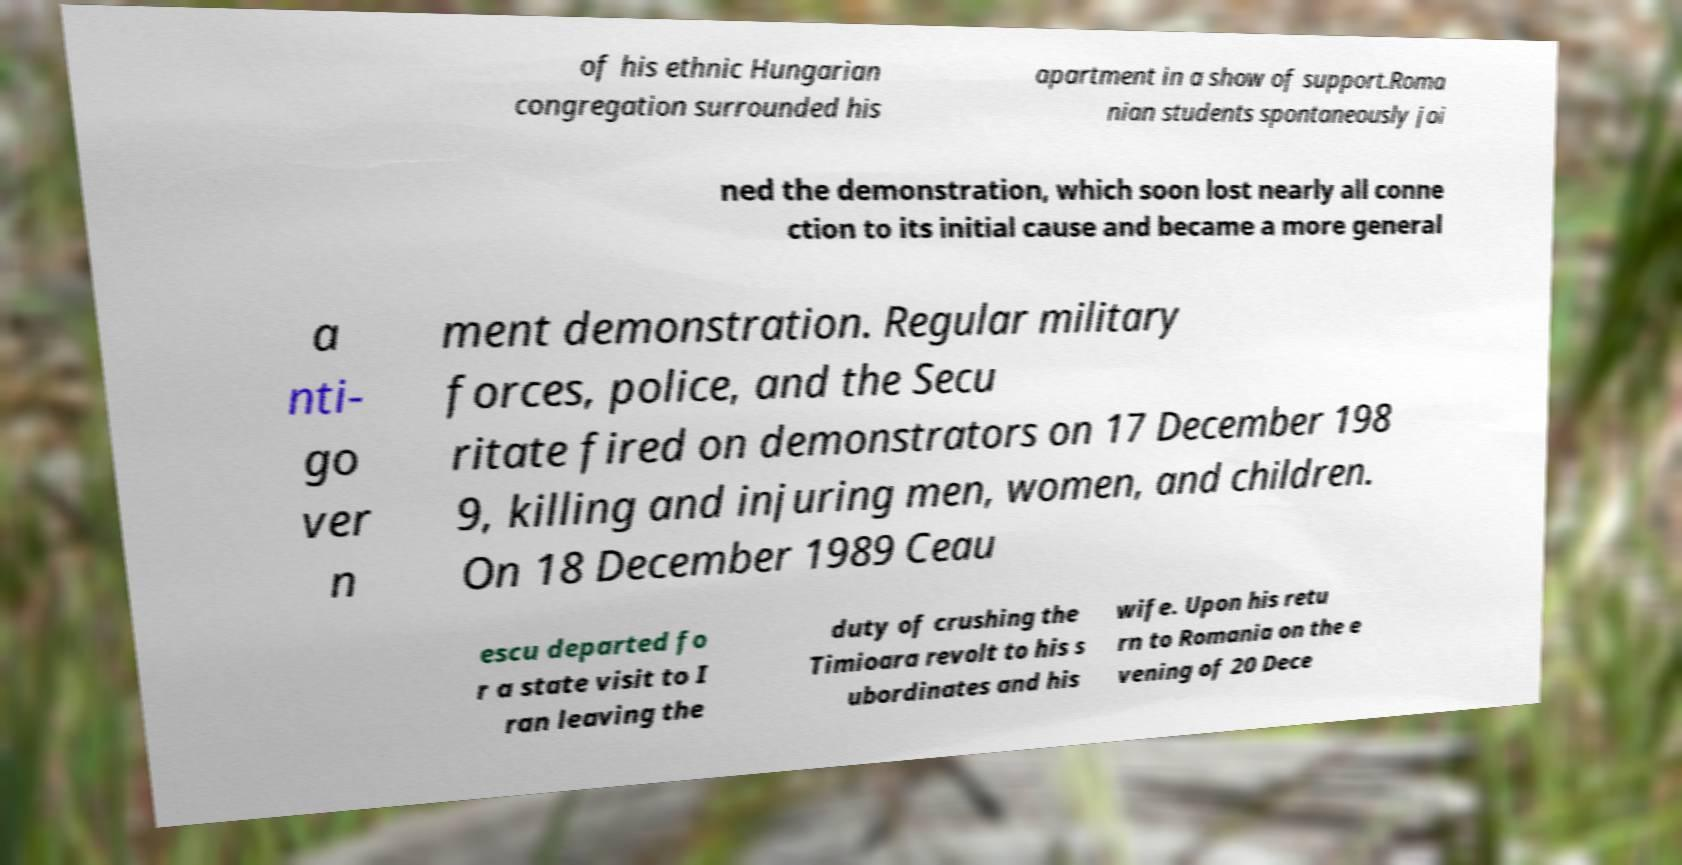Can you read and provide the text displayed in the image?This photo seems to have some interesting text. Can you extract and type it out for me? of his ethnic Hungarian congregation surrounded his apartment in a show of support.Roma nian students spontaneously joi ned the demonstration, which soon lost nearly all conne ction to its initial cause and became a more general a nti- go ver n ment demonstration. Regular military forces, police, and the Secu ritate fired on demonstrators on 17 December 198 9, killing and injuring men, women, and children. On 18 December 1989 Ceau escu departed fo r a state visit to I ran leaving the duty of crushing the Timioara revolt to his s ubordinates and his wife. Upon his retu rn to Romania on the e vening of 20 Dece 